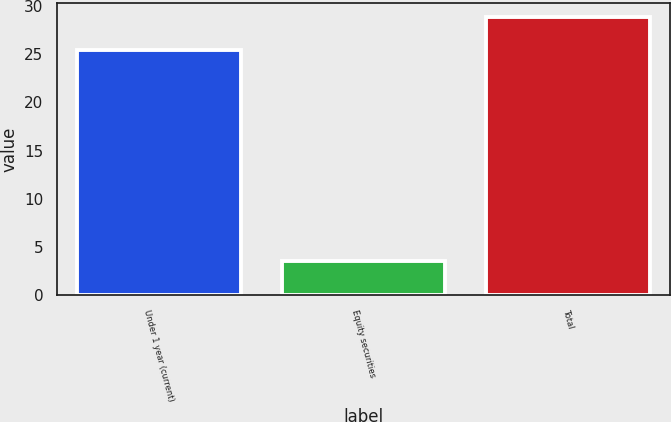Convert chart to OTSL. <chart><loc_0><loc_0><loc_500><loc_500><bar_chart><fcel>Under 1 year (current)<fcel>Equity securities<fcel>Total<nl><fcel>25.4<fcel>3.5<fcel>28.9<nl></chart> 